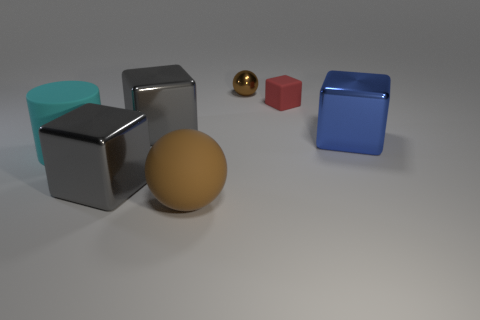How many objects are tiny things that are right of the brown metal ball or objects that are to the left of the large matte ball?
Your answer should be compact. 4. There is a big cylinder; is it the same color as the ball to the right of the big rubber ball?
Offer a terse response. No. What shape is the cyan object that is made of the same material as the small red object?
Make the answer very short. Cylinder. How many gray blocks are there?
Offer a very short reply. 2. How many things are metallic cubes on the left side of the matte block or big brown shiny cylinders?
Your answer should be compact. 2. There is a shiny block right of the large brown rubber object; is its color the same as the tiny block?
Your answer should be compact. No. How many other things are there of the same color as the big matte cylinder?
Your answer should be very brief. 0. How many tiny things are cubes or cyan cylinders?
Keep it short and to the point. 1. Are there more large brown matte objects than small gray metal balls?
Ensure brevity in your answer.  Yes. Is the material of the cyan cylinder the same as the small red block?
Your answer should be very brief. Yes. 